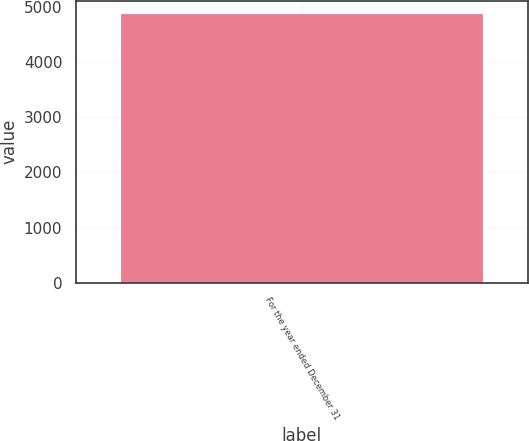Convert chart to OTSL. <chart><loc_0><loc_0><loc_500><loc_500><bar_chart><fcel>For the year ended December 31<nl><fcel>4866<nl></chart> 